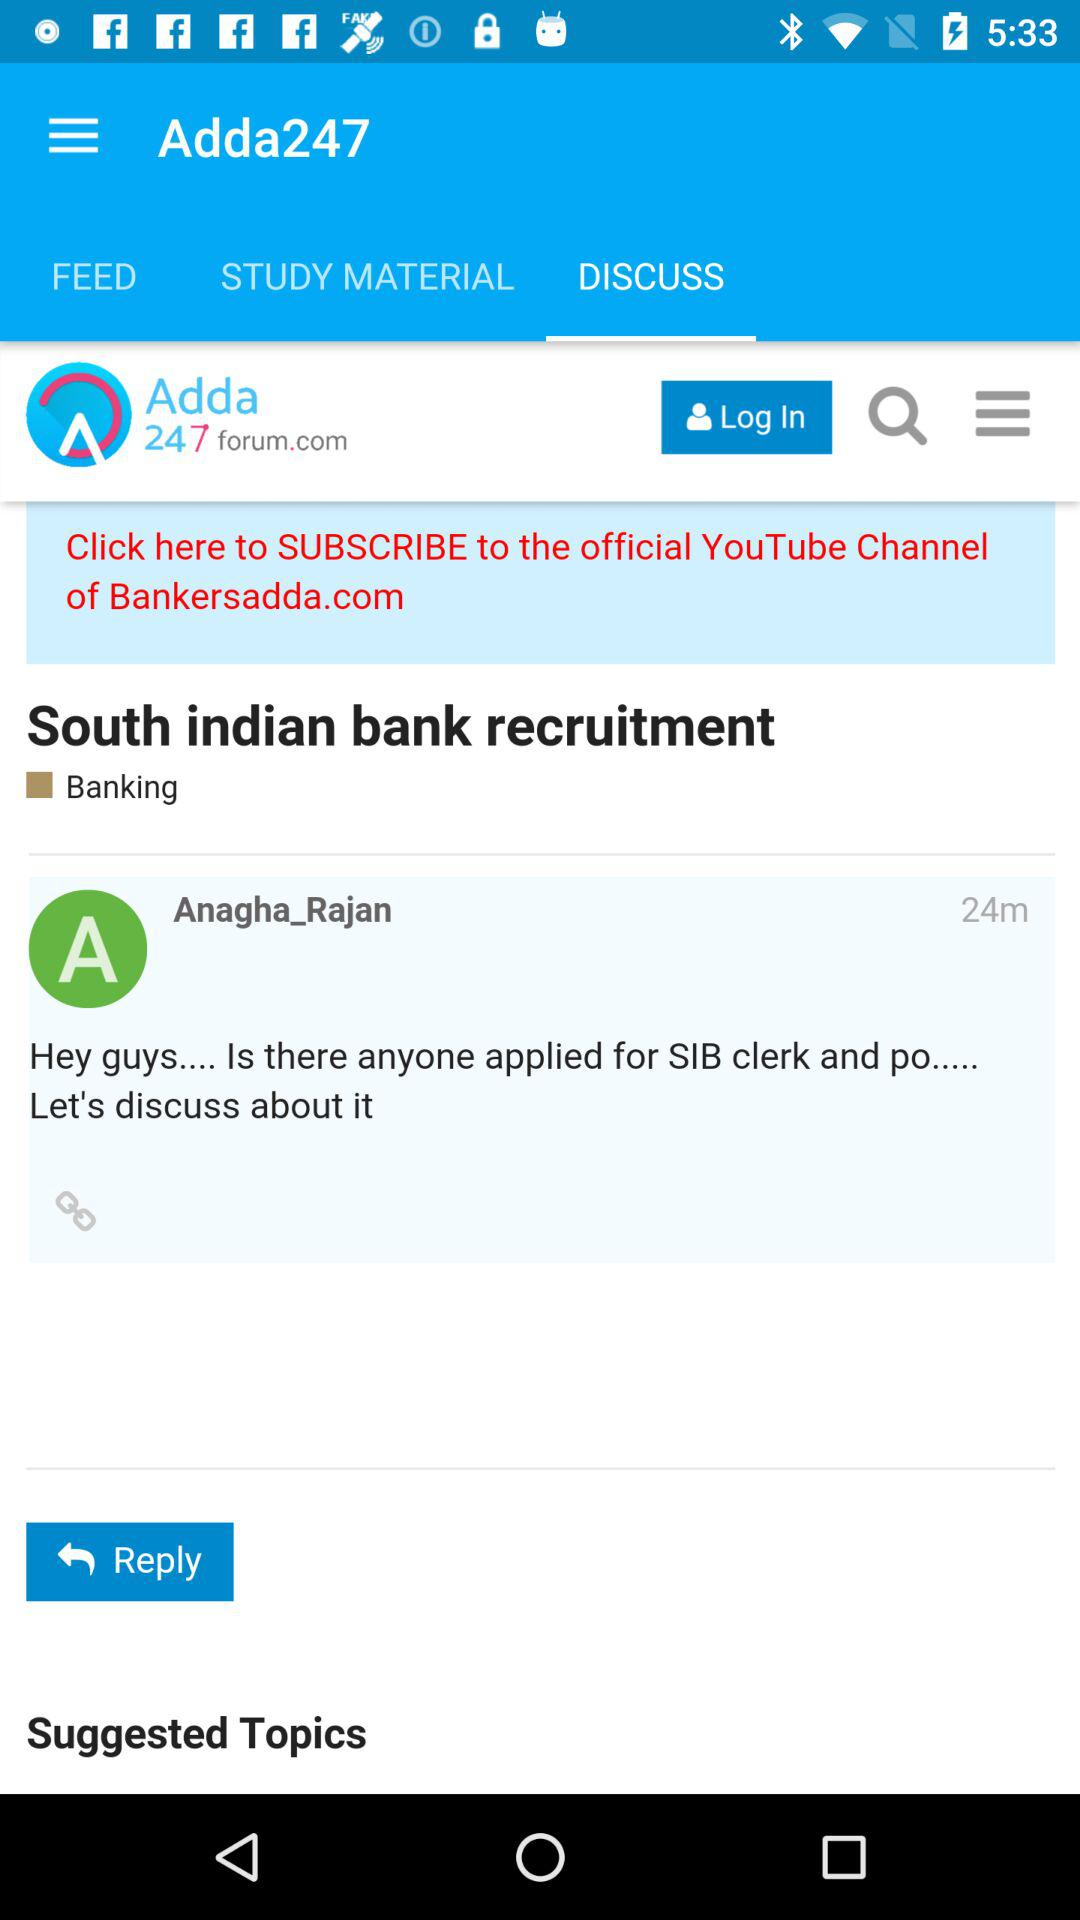How many minutes ago did Anagha_Rajan post the comment? Anagha_Rajan posted the comment 24 minutes ago. 